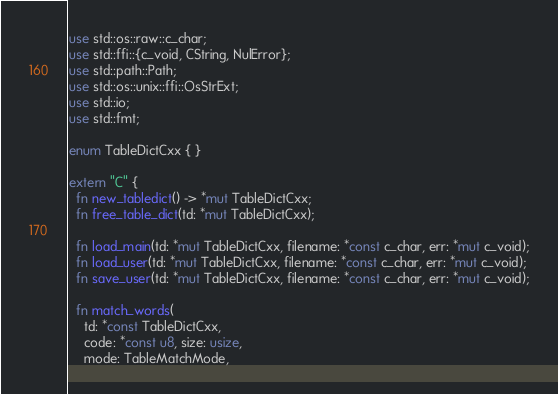Convert code to text. <code><loc_0><loc_0><loc_500><loc_500><_Rust_>use std::os::raw::c_char;
use std::ffi::{c_void, CString, NulError};
use std::path::Path;
use std::os::unix::ffi::OsStrExt;
use std::io;
use std::fmt;

enum TableDictCxx { }

extern "C" {
  fn new_tabledict() -> *mut TableDictCxx;
  fn free_table_dict(td: *mut TableDictCxx);

  fn load_main(td: *mut TableDictCxx, filename: *const c_char, err: *mut c_void);
  fn load_user(td: *mut TableDictCxx, filename: *const c_char, err: *mut c_void);
  fn save_user(td: *mut TableDictCxx, filename: *const c_char, err: *mut c_void);

  fn match_words(
    td: *const TableDictCxx,
    code: *const u8, size: usize,
    mode: TableMatchMode,</code> 